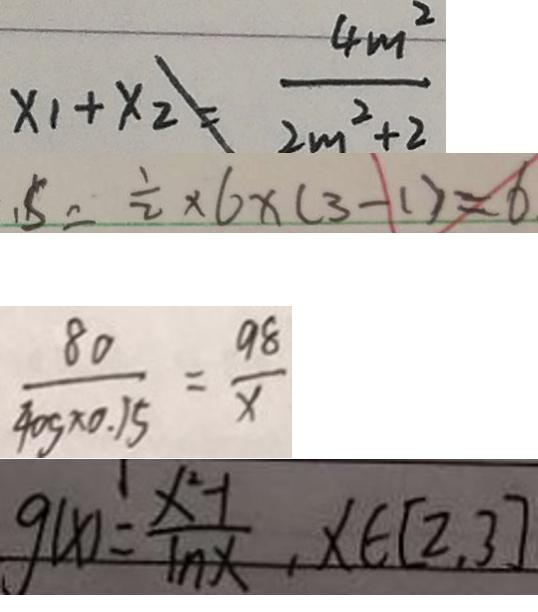<formula> <loc_0><loc_0><loc_500><loc_500>x _ { 1 } + x _ { 2 } \neq \frac { 4 m ^ { 2 } } { 2 m ^ { 2 } + 2 } 
 , S = \frac { 1 } { 2 } \times 6 \times ( 3 - 1 ) = 6 
 \frac { 8 0 } { 4 0 g \times 0 . 1 5 } = \frac { 9 8 } { x } 
 g ( x ) = \frac { x ^ { 2 } - 1 } { 1 n x } , x \in [ 2 , 3 ]</formula> 